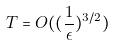Convert formula to latex. <formula><loc_0><loc_0><loc_500><loc_500>T = O ( ( \frac { 1 } { \epsilon } ) ^ { 3 / 2 } )</formula> 